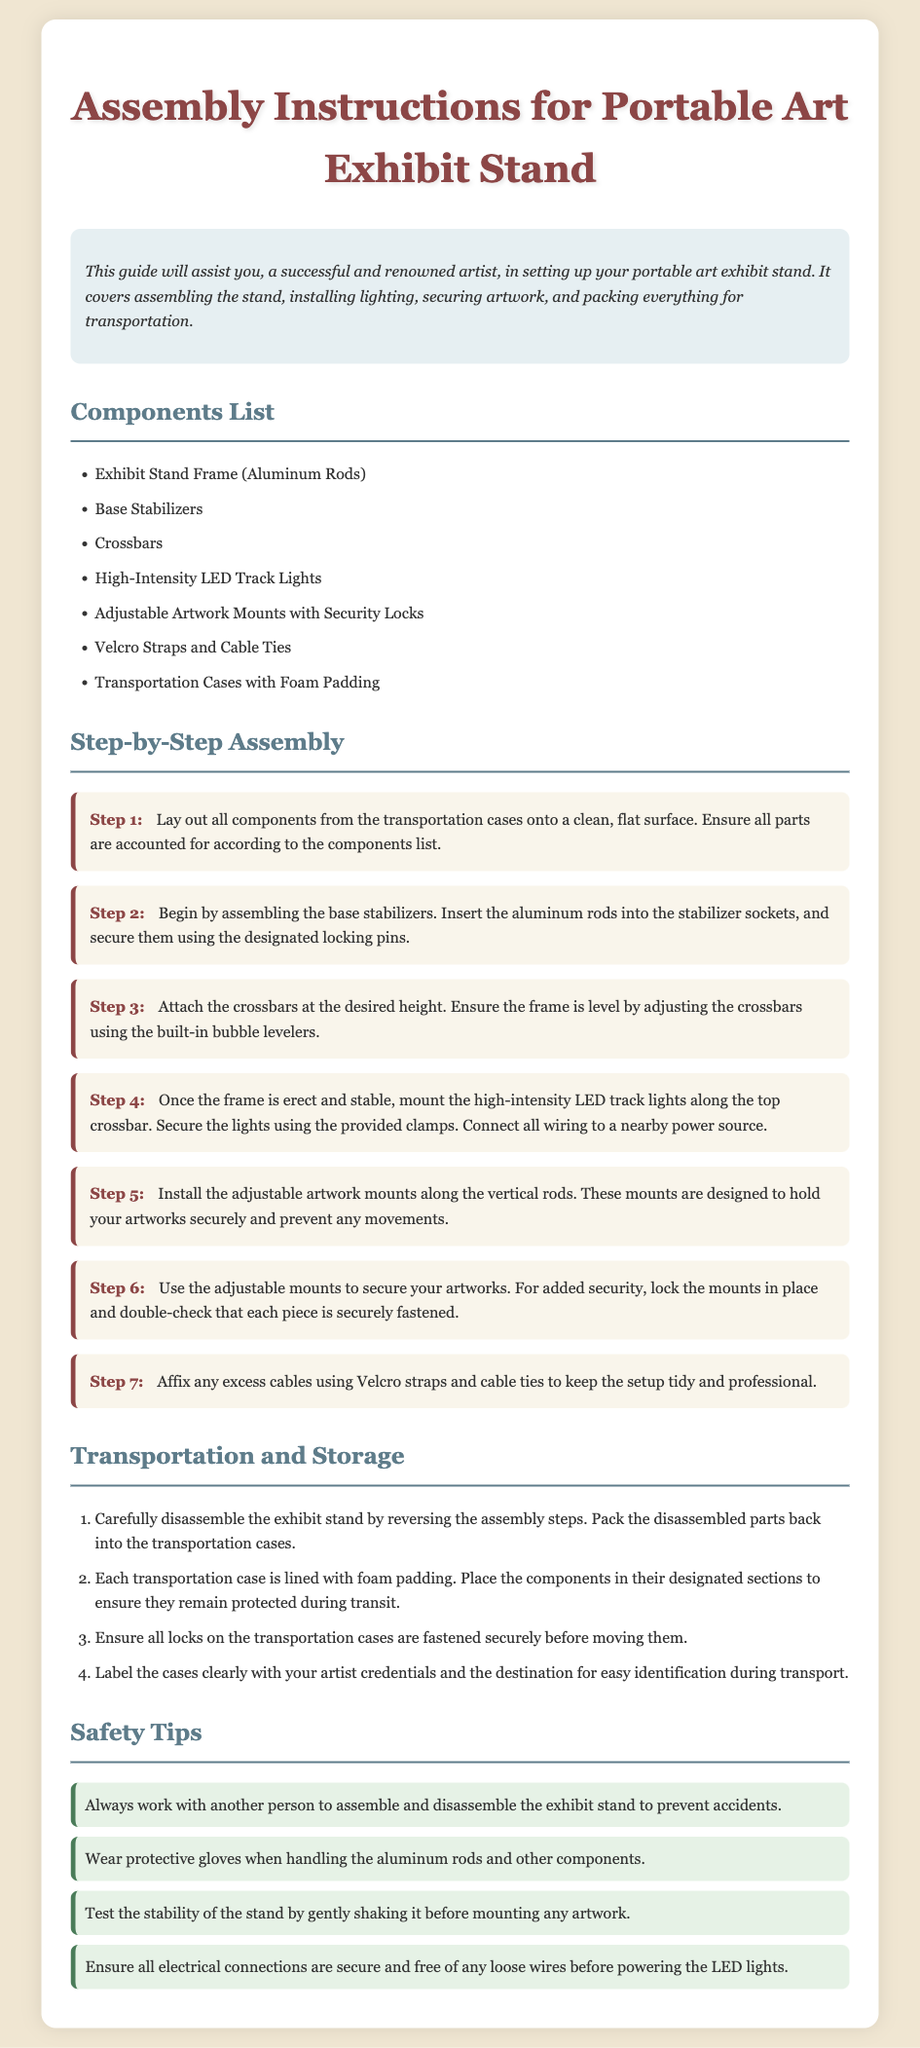What are the main components for the exhibit stand? The main components are listed in the document under "Components List".
Answer: Exhibit Stand Frame, Base Stabilizers, Crossbars, High-Intensity LED Track Lights, Adjustable Artwork Mounts, Velcro Straps, Transportation Cases How many steps are there in the assembly instructions? The document outlines the assembly instructions in a section dedicated to "Step-by-Step Assembly".
Answer: Seven What should be packed with the exhibit during transportation? The instructions contain a section that explains how to prepare the exhibit for transport.
Answer: Disassembled parts What is the purpose of the safety tips? The section "Safety Tips" outlines precautions for assembly and disassembly.
Answer: Prevent accidents What must be checked before powering the LED lights? This information can be found in the safety tips section, which highlights necessary checks before powering the equipment.
Answer: Electrical connections What is required for added security when installing artwork? The installation instructions specify a step for securing artwork.
Answer: Lock the mounts What material is the exhibit stand frame made from? The material used for the exhibit stand frame is mentioned in the components list.
Answer: Aluminum Rods Where should excess cables be affixed? This detail on cable management is found under the final assembly step.
Answer: Velcro straps and cable ties 